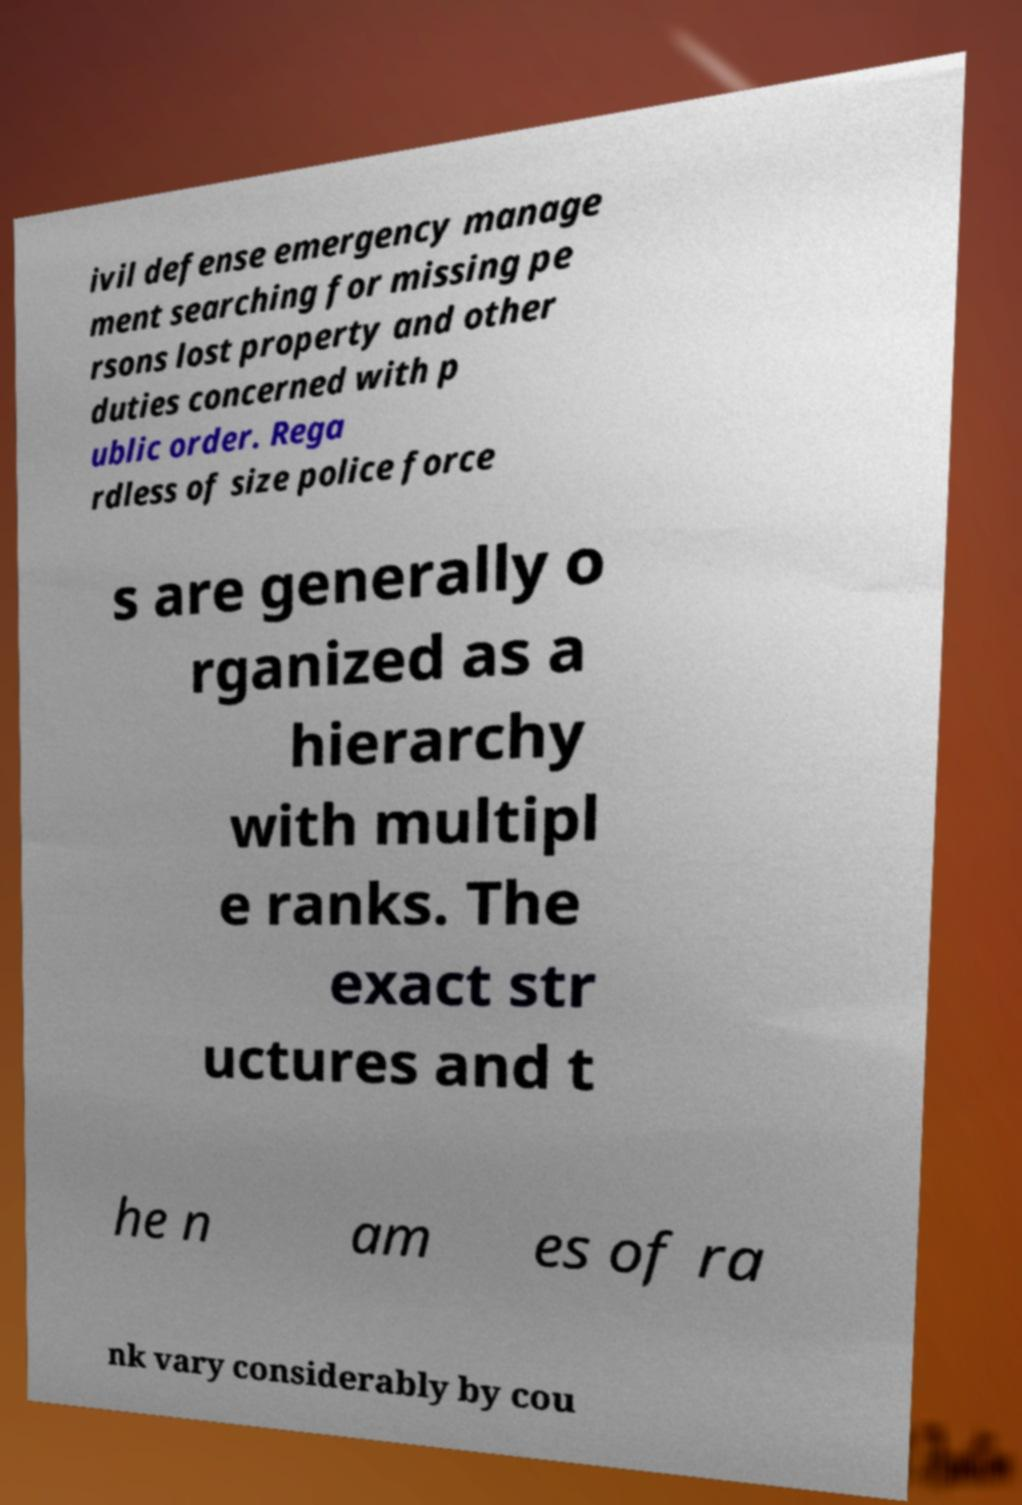Can you read and provide the text displayed in the image?This photo seems to have some interesting text. Can you extract and type it out for me? ivil defense emergency manage ment searching for missing pe rsons lost property and other duties concerned with p ublic order. Rega rdless of size police force s are generally o rganized as a hierarchy with multipl e ranks. The exact str uctures and t he n am es of ra nk vary considerably by cou 